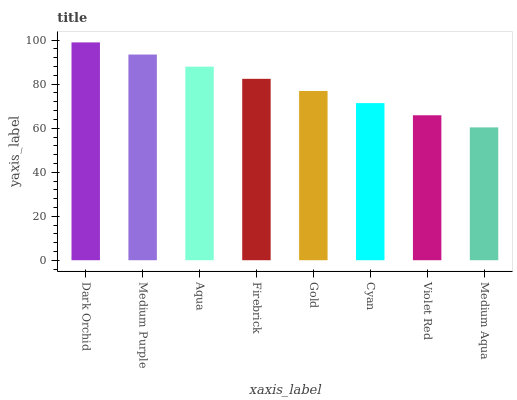Is Medium Aqua the minimum?
Answer yes or no. Yes. Is Dark Orchid the maximum?
Answer yes or no. Yes. Is Medium Purple the minimum?
Answer yes or no. No. Is Medium Purple the maximum?
Answer yes or no. No. Is Dark Orchid greater than Medium Purple?
Answer yes or no. Yes. Is Medium Purple less than Dark Orchid?
Answer yes or no. Yes. Is Medium Purple greater than Dark Orchid?
Answer yes or no. No. Is Dark Orchid less than Medium Purple?
Answer yes or no. No. Is Firebrick the high median?
Answer yes or no. Yes. Is Gold the low median?
Answer yes or no. Yes. Is Dark Orchid the high median?
Answer yes or no. No. Is Aqua the low median?
Answer yes or no. No. 